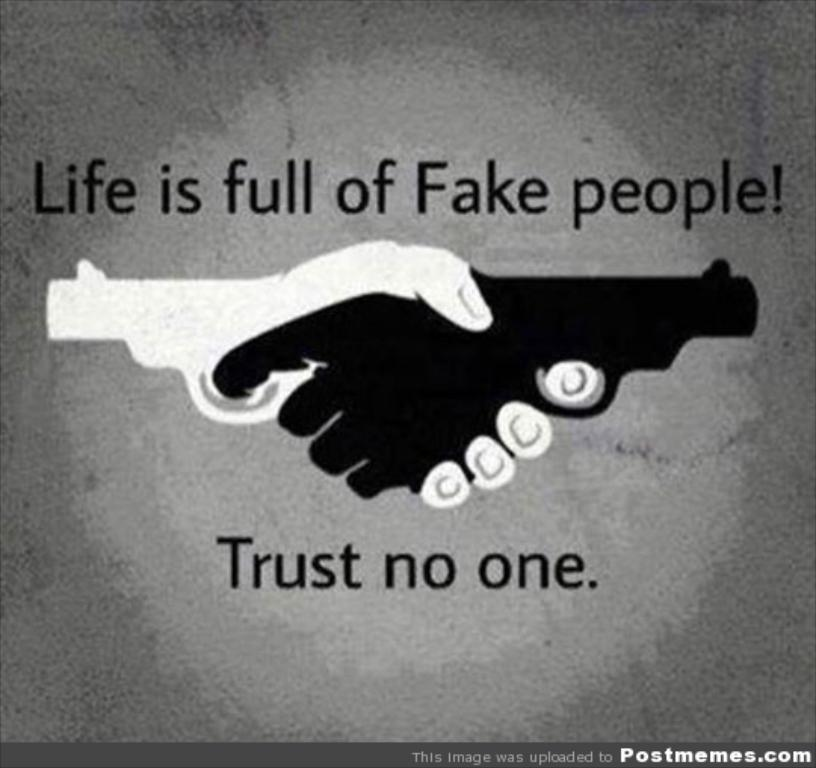<image>
Write a terse but informative summary of the picture. A poster of two hands shaking that says "Life is fun of Fake people!" 